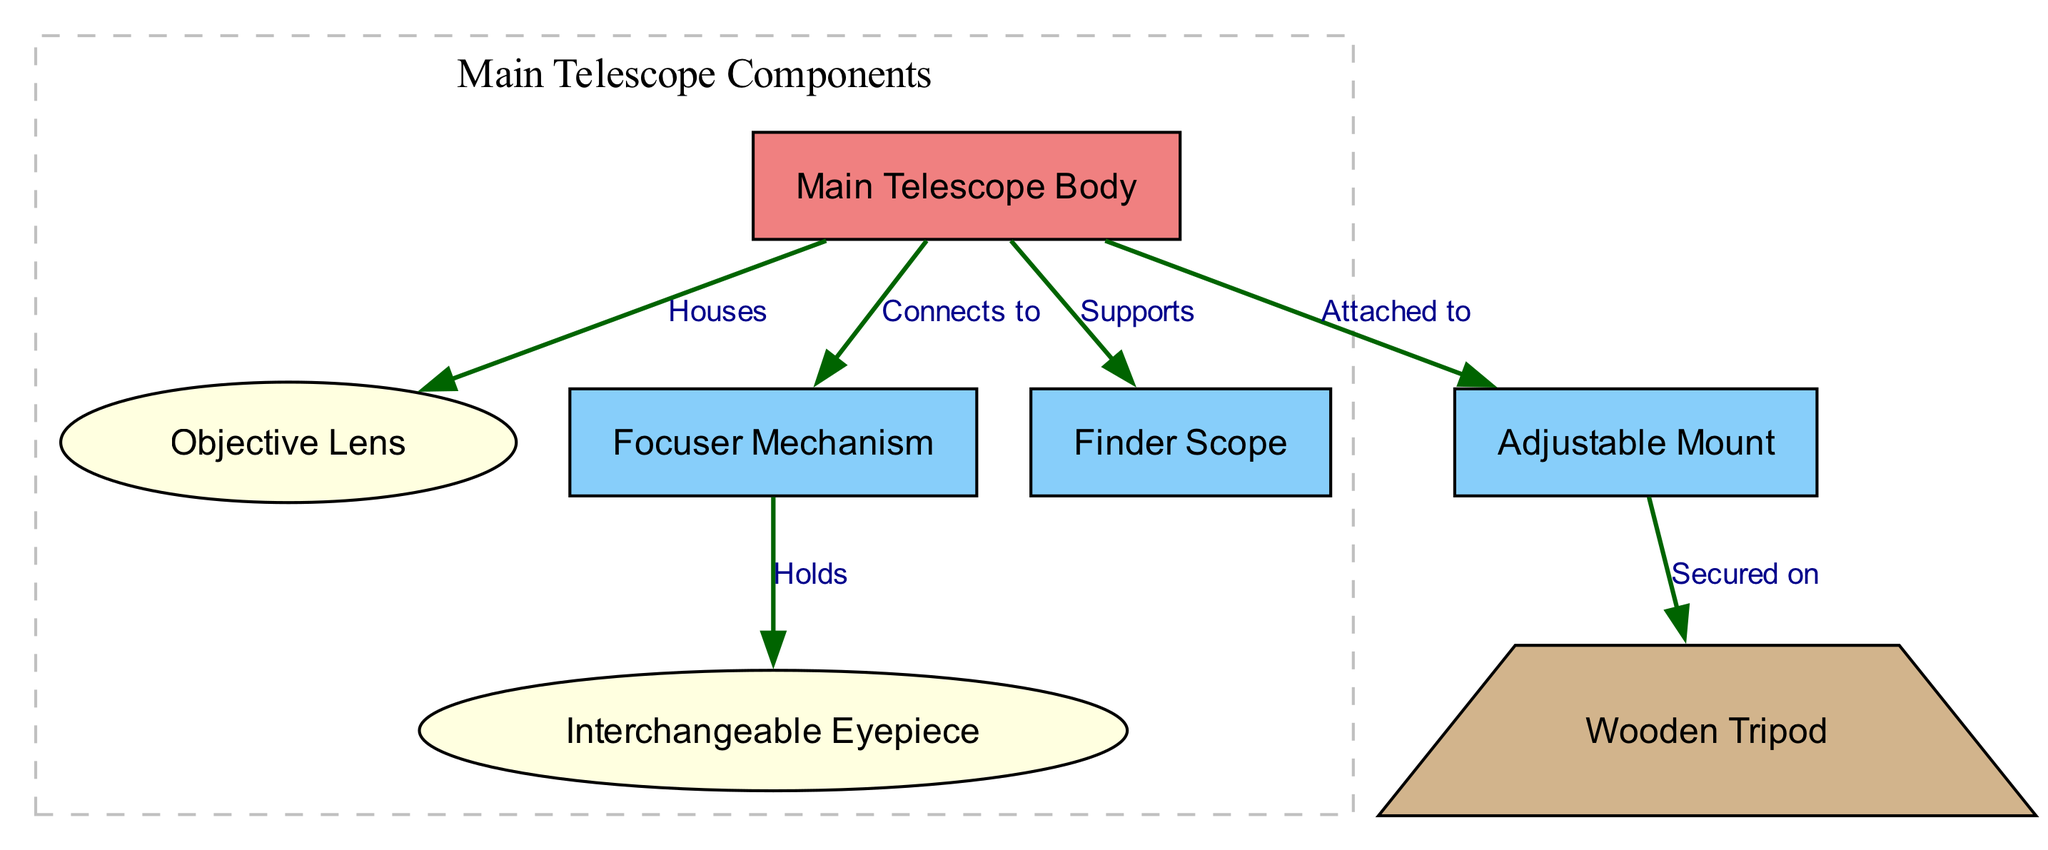What is the main component of the telescope? The diagram identifies the "Main Telescope Body" as the primary component, denoted with a larger rectangle visually distinguishing it from the other parts.
Answer: Main Telescope Body How many lenses are present in the design? The diagram features an "Objective Lens" and an "Interchangeable Eyepiece," both categorized as lenses, allowing us to count a total of two.
Answer: 2 Which component is supported by the main telescope body? The diagram states that the "Finder Scope" is supported by the "Main Telescope Body," shown with an arrow connecting the two components.
Answer: Finder Scope What part connects to the focuser? According to the diagram, the "Interchangeable Eyepiece" is the component that the "Focuser Mechanism" holds, linking both through a directional edge labeled "Holds."
Answer: Interchangeable Eyepiece What type of mount is used in this telescope design? The diagram specifies an "Adjustable Mount" which connects to the main body of the telescope and is then secured on the "Wooden Tripod." This mount type is indicated clearly in the plan.
Answer: Adjustable Mount Which part is housed within the telescope body? The "Objective Lens," according to the diagram, is housed within the "Main Telescope Body," as indicated by the edge labeled "Houses."
Answer: Objective Lens What shape represents the wooden tripod? The diagram features the "Wooden Tripod" outlined as a trapezium, which is a distinctive shape not used for other components in the design, making it easily identifiable.
Answer: Trapezium Which component is directly connected to the adjustable mount? The diagram shows that the "Wooden Tripod" is the component secured on the "Adjustable Mount," illustrating their relationship clearly through an arrow.
Answer: Wooden Tripod Where does the focuser mechanism connect in the assembly? The diagram indicates that the "Focuser Mechanism" connects to the "Main Telescope Body," establishing this connection with a directional edge labeled "Connects to."
Answer: Main Telescope Body 